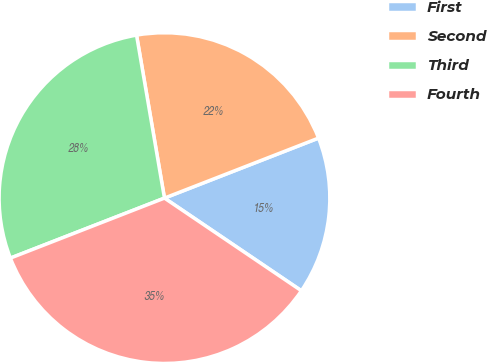Convert chart to OTSL. <chart><loc_0><loc_0><loc_500><loc_500><pie_chart><fcel>First<fcel>Second<fcel>Third<fcel>Fourth<nl><fcel>15.38%<fcel>21.79%<fcel>28.21%<fcel>34.62%<nl></chart> 